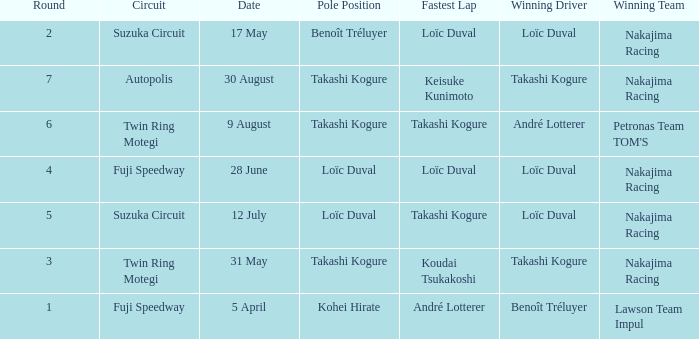How many drivers drove on Suzuka Circuit where Loïc Duval took pole position? 1.0. 